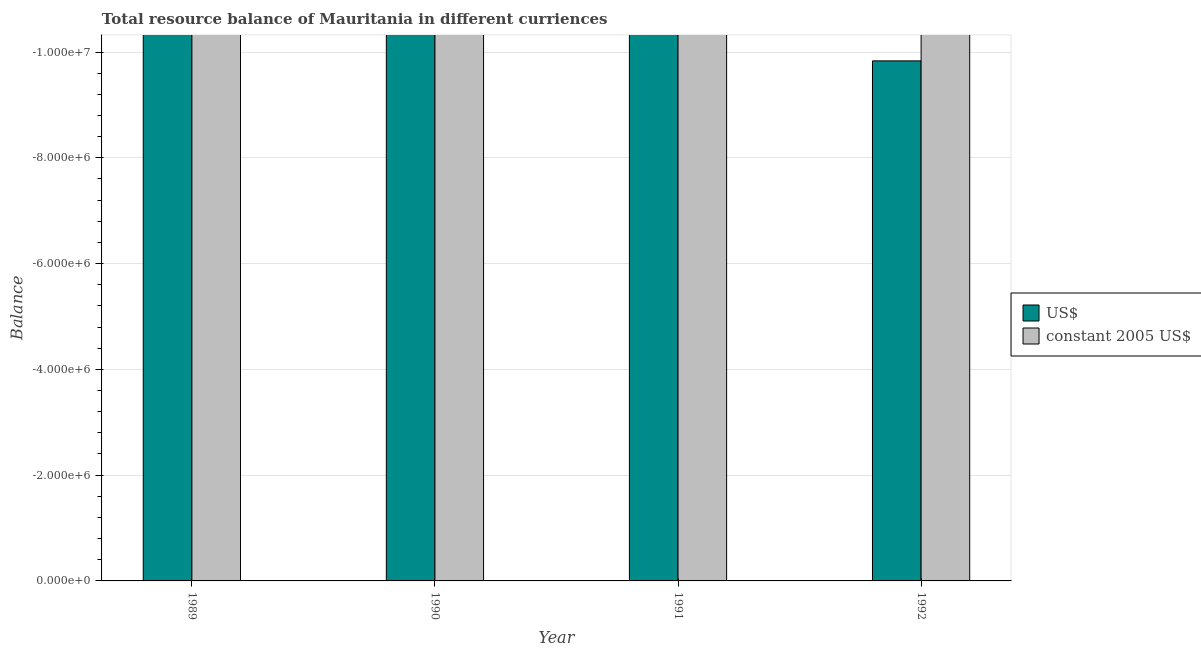How many different coloured bars are there?
Ensure brevity in your answer.  0. Are the number of bars per tick equal to the number of legend labels?
Your response must be concise. No. How many bars are there on the 3rd tick from the left?
Your response must be concise. 0. How many bars are there on the 2nd tick from the right?
Keep it short and to the point. 0. What is the label of the 3rd group of bars from the left?
Your response must be concise. 1991. What is the resource balance in us$ in 1991?
Provide a short and direct response. 0. Across all years, what is the minimum resource balance in constant us$?
Provide a succinct answer. 0. What is the total resource balance in us$ in the graph?
Offer a terse response. 0. What is the difference between the resource balance in us$ in 1990 and the resource balance in constant us$ in 1992?
Your response must be concise. 0. What is the average resource balance in us$ per year?
Your answer should be compact. 0. In how many years, is the resource balance in us$ greater than -400000 units?
Your response must be concise. 0. In how many years, is the resource balance in us$ greater than the average resource balance in us$ taken over all years?
Your response must be concise. 0. How many bars are there?
Offer a very short reply. 0. Are all the bars in the graph horizontal?
Give a very brief answer. No. What is the difference between two consecutive major ticks on the Y-axis?
Offer a terse response. 2.00e+06. Does the graph contain any zero values?
Provide a short and direct response. Yes. Does the graph contain grids?
Provide a short and direct response. Yes. How many legend labels are there?
Your response must be concise. 2. How are the legend labels stacked?
Offer a very short reply. Vertical. What is the title of the graph?
Make the answer very short. Total resource balance of Mauritania in different curriences. What is the label or title of the Y-axis?
Your answer should be very brief. Balance. What is the Balance in constant 2005 US$ in 1990?
Offer a terse response. 0. What is the Balance of US$ in 1991?
Keep it short and to the point. 0. What is the Balance in constant 2005 US$ in 1991?
Keep it short and to the point. 0. What is the Balance of US$ in 1992?
Ensure brevity in your answer.  0. What is the total Balance of US$ in the graph?
Provide a short and direct response. 0. What is the average Balance in US$ per year?
Your response must be concise. 0. 